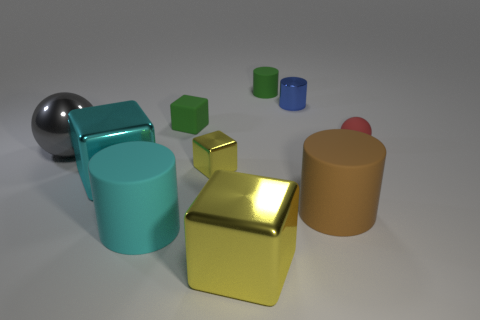Subtract all tiny yellow blocks. How many blocks are left? 3 Subtract all red spheres. How many spheres are left? 1 Subtract 1 balls. How many balls are left? 1 Subtract all spheres. How many objects are left? 8 Add 1 cyan rubber things. How many cyan rubber things exist? 2 Subtract 1 green cylinders. How many objects are left? 9 Subtract all blue balls. Subtract all red cylinders. How many balls are left? 2 Subtract all purple spheres. How many brown cylinders are left? 1 Subtract all brown things. Subtract all tiny green cubes. How many objects are left? 8 Add 2 green matte blocks. How many green matte blocks are left? 3 